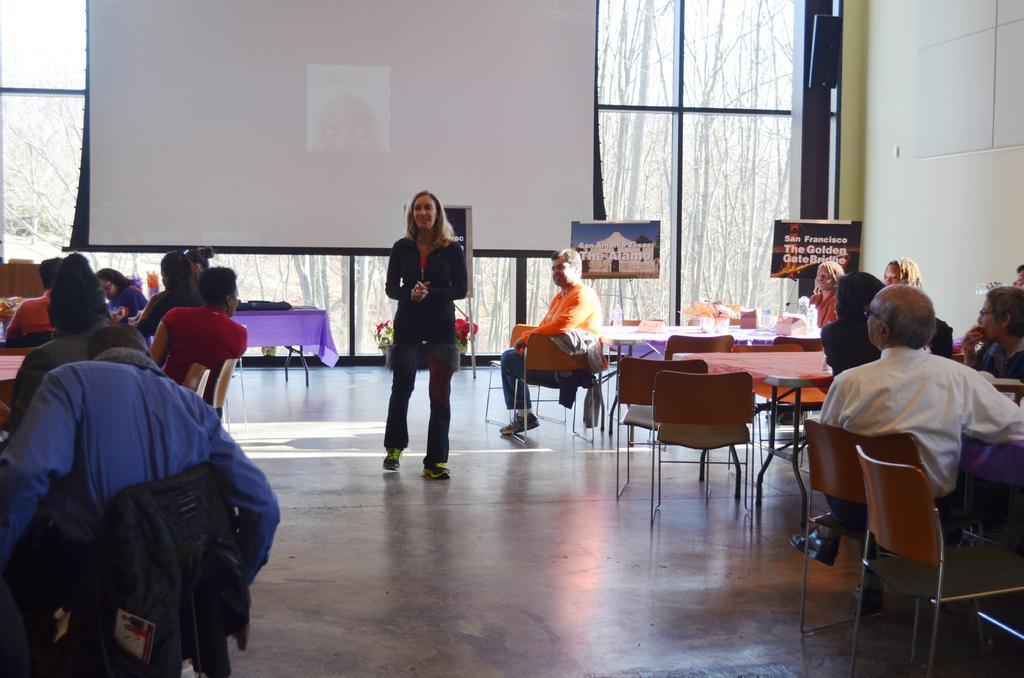In one or two sentences, can you explain what this image depicts? In the picture we can see a people sitting on a chairs near the tables, to a left hand side and some people are sitting on the right hand side and tables, and one woman is standing and explaining something to them, behind her there is a white color screen, in the back side we can see a screen and in the background we can see a glass wall from it we can see a trees. 